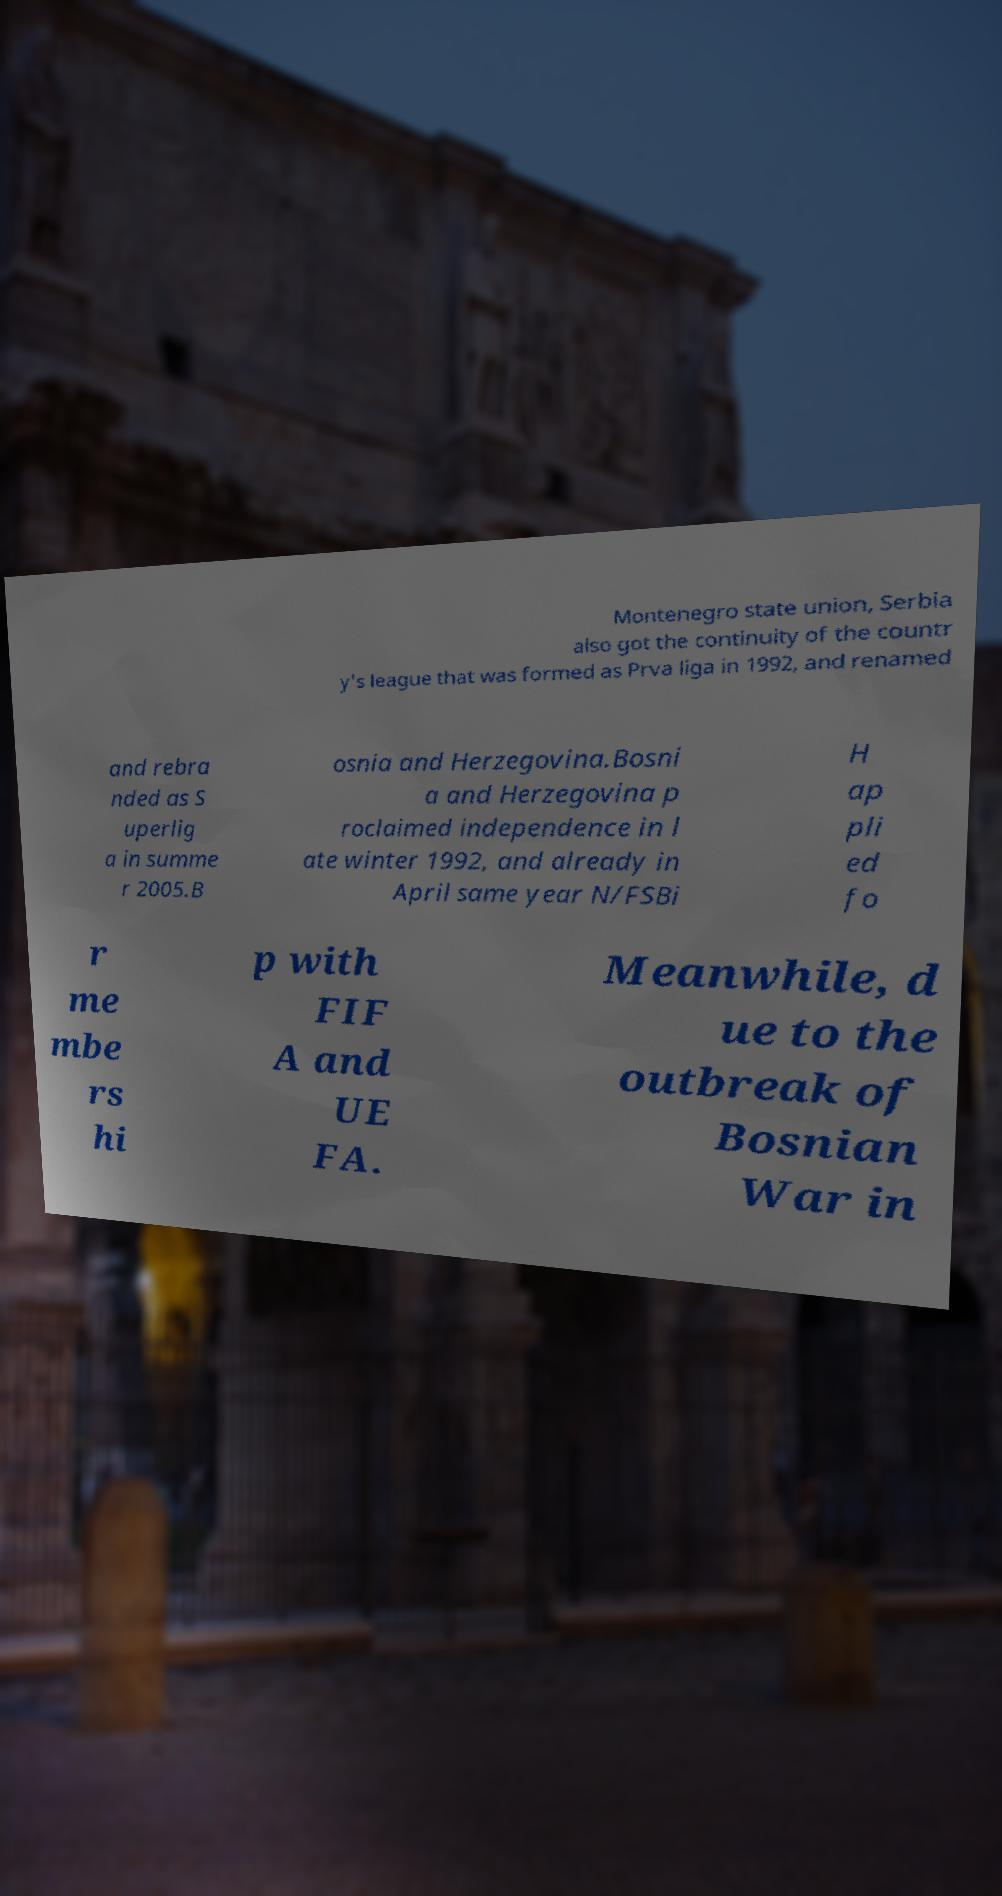There's text embedded in this image that I need extracted. Can you transcribe it verbatim? Montenegro state union, Serbia also got the continuity of the countr y's league that was formed as Prva liga in 1992, and renamed and rebra nded as S uperlig a in summe r 2005.B osnia and Herzegovina.Bosni a and Herzegovina p roclaimed independence in l ate winter 1992, and already in April same year N/FSBi H ap pli ed fo r me mbe rs hi p with FIF A and UE FA. Meanwhile, d ue to the outbreak of Bosnian War in 